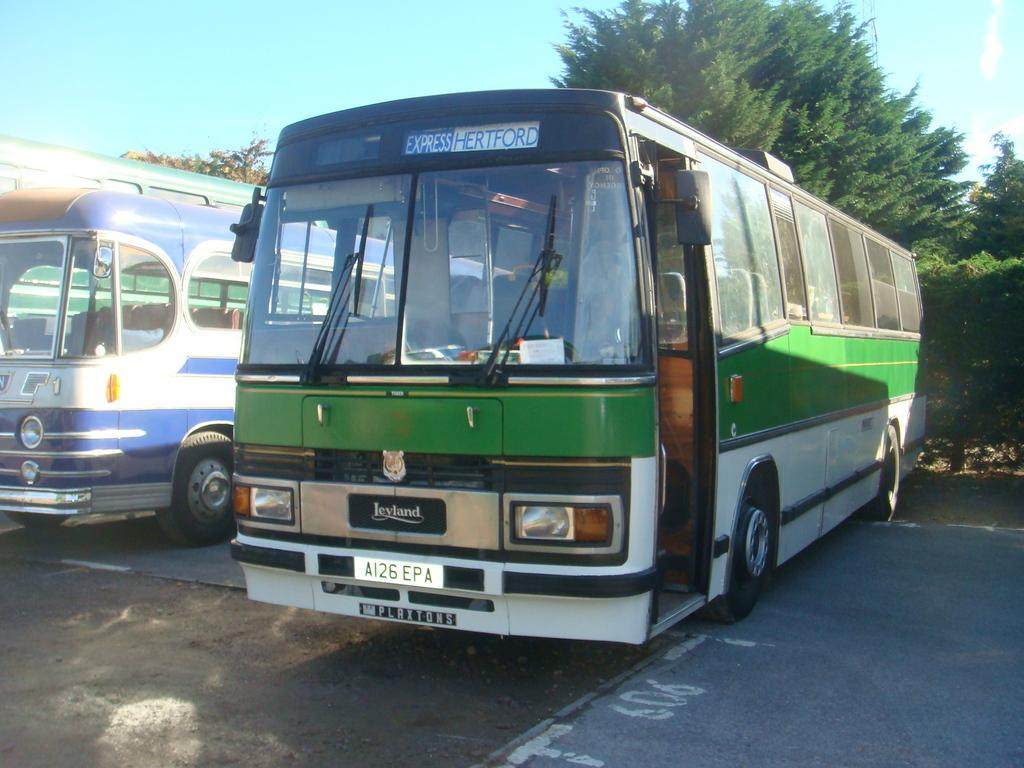<image>
Relay a brief, clear account of the picture shown. A green and white express bus going to Hertford. 